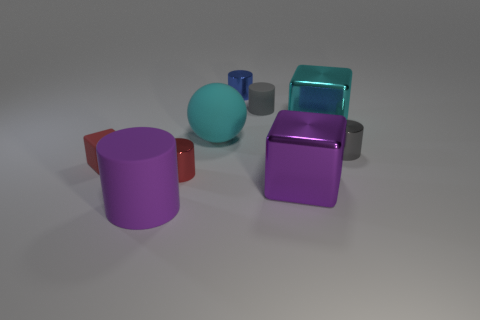How big is the purple thing left of the blue metal cylinder?
Your answer should be compact. Large. How big is the gray metal thing?
Provide a succinct answer. Small. What number of cubes are large cyan rubber things or large cyan objects?
Give a very brief answer. 1. There is another cylinder that is the same material as the big cylinder; what is its size?
Give a very brief answer. Small. How many tiny metal objects are the same color as the rubber block?
Give a very brief answer. 1. There is a gray rubber object; are there any spheres behind it?
Provide a succinct answer. No. Does the large purple metallic thing have the same shape as the big shiny object that is behind the red rubber object?
Ensure brevity in your answer.  Yes. What number of things are either small objects that are left of the small gray rubber object or shiny cubes?
Make the answer very short. 5. How many large things are both in front of the large purple cube and behind the tiny matte cube?
Your answer should be very brief. 0. What number of things are either tiny gray cylinders in front of the big rubber sphere or cylinders to the left of the small gray matte object?
Your response must be concise. 4. 